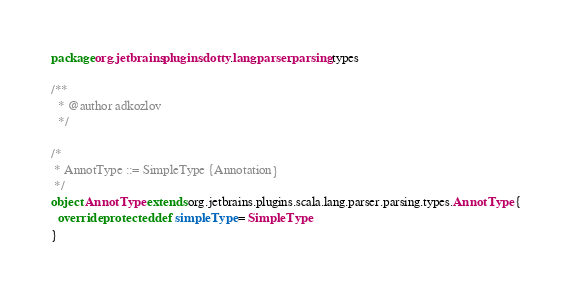Convert code to text. <code><loc_0><loc_0><loc_500><loc_500><_Scala_>package org.jetbrains.plugins.dotty.lang.parser.parsing.types

/**
  * @author adkozlov
  */

/*
 * AnnotType ::= SimpleType {Annotation}
 */
object AnnotType extends org.jetbrains.plugins.scala.lang.parser.parsing.types.AnnotType {
  override protected def simpleType = SimpleType
}
</code> 